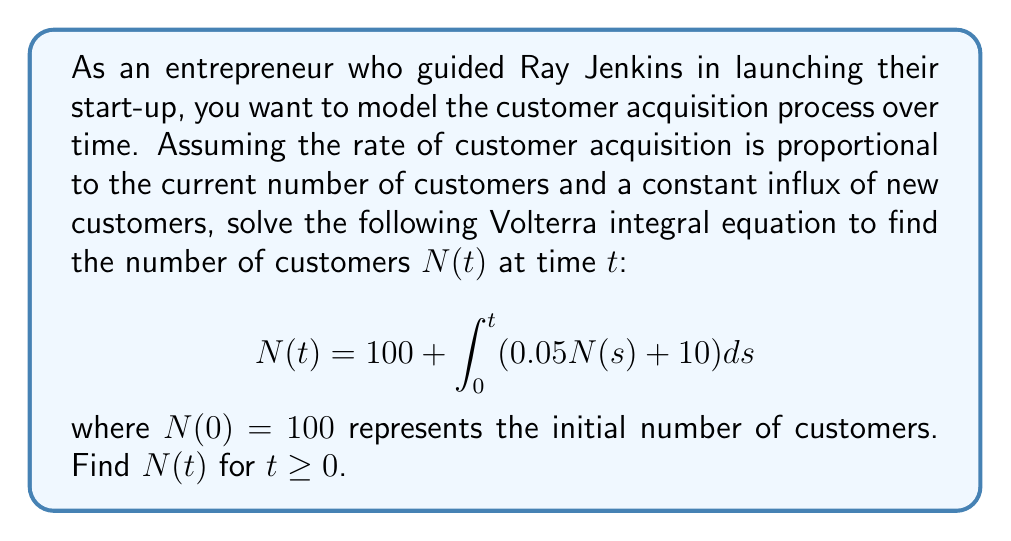Help me with this question. To solve this Volterra integral equation, we'll follow these steps:

1) First, we recognize that this is a linear Volterra equation of the second kind.

2) We differentiate both sides with respect to $t$:
   $$\frac{d}{dt}N(t) = \frac{d}{dt}\left(100 + \int_0^t (0.05N(s) + 10) ds\right)$$

3) Using the Fundamental Theorem of Calculus:
   $$\frac{dN}{dt} = 0.05N(t) + 10$$

4) This is now a first-order linear differential equation. We can solve it using the integrating factor method.

5) The integrating factor is $e^{-0.05t}$. Multiplying both sides:
   $$e^{-0.05t}\frac{dN}{dt} - 0.05e^{-0.05t}N = 10e^{-0.05t}$$

6) The left side is now the derivative of $e^{-0.05t}N$. So:
   $$\frac{d}{dt}(e^{-0.05t}N) = 10e^{-0.05t}$$

7) Integrating both sides:
   $$e^{-0.05t}N = -200e^{-0.05t} + C$$

8) Solving for $N(t)$:
   $$N(t) = -200 + Ce^{0.05t}$$

9) Using the initial condition $N(0) = 100$:
   $$100 = -200 + C$$
   $$C = 300$$

10) Therefore, the final solution is:
    $$N(t) = -200 + 300e^{0.05t}$$

This represents the number of customers at time $t$.
Answer: $N(t) = -200 + 300e^{0.05t}$ 